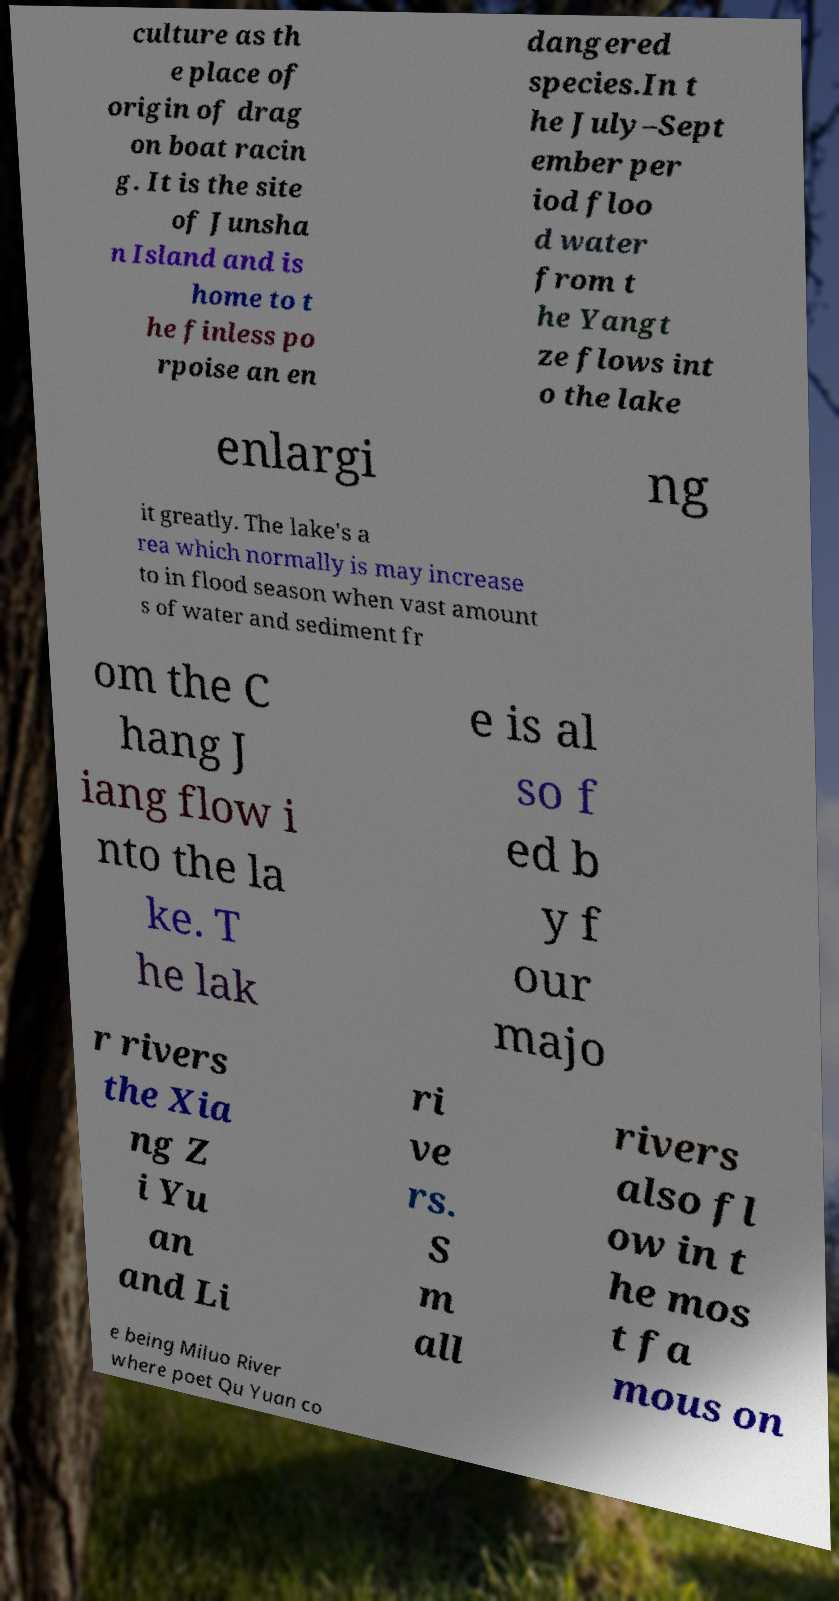I need the written content from this picture converted into text. Can you do that? culture as th e place of origin of drag on boat racin g. It is the site of Junsha n Island and is home to t he finless po rpoise an en dangered species.In t he July–Sept ember per iod floo d water from t he Yangt ze flows int o the lake enlargi ng it greatly. The lake's a rea which normally is may increase to in flood season when vast amount s of water and sediment fr om the C hang J iang flow i nto the la ke. T he lak e is al so f ed b y f our majo r rivers the Xia ng Z i Yu an and Li ri ve rs. S m all rivers also fl ow in t he mos t fa mous on e being Miluo River where poet Qu Yuan co 